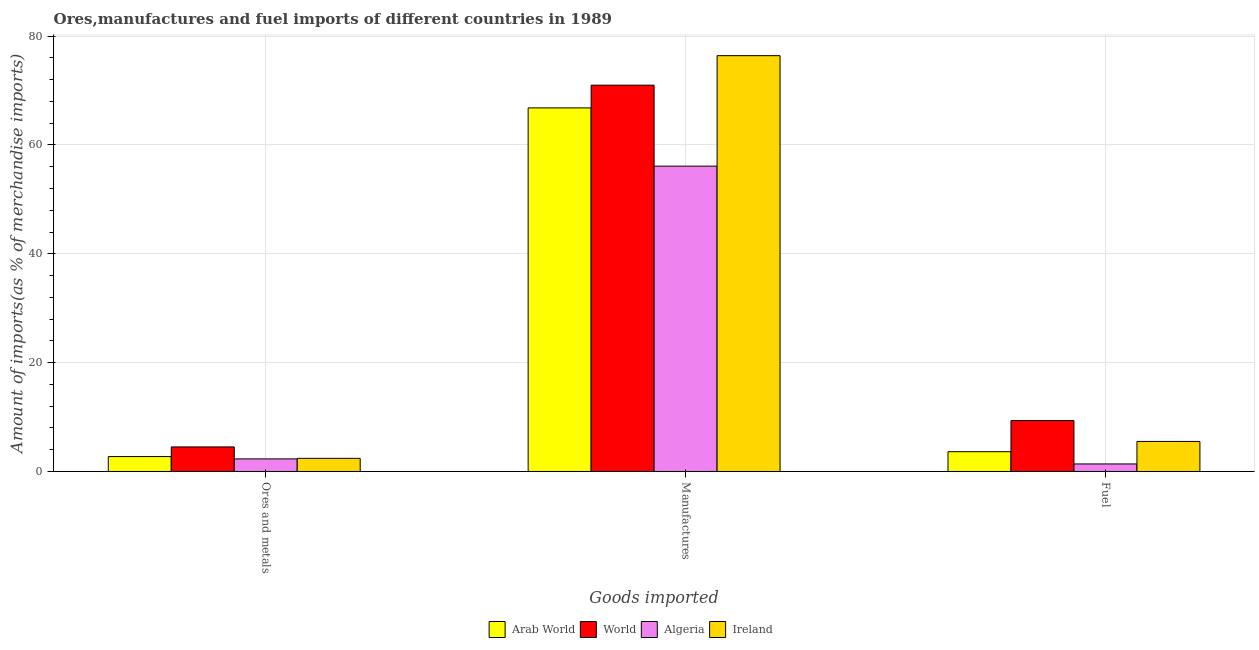How many different coloured bars are there?
Your answer should be very brief. 4. Are the number of bars per tick equal to the number of legend labels?
Offer a very short reply. Yes. How many bars are there on the 2nd tick from the left?
Offer a very short reply. 4. How many bars are there on the 2nd tick from the right?
Keep it short and to the point. 4. What is the label of the 1st group of bars from the left?
Give a very brief answer. Ores and metals. What is the percentage of fuel imports in Ireland?
Ensure brevity in your answer.  5.52. Across all countries, what is the maximum percentage of manufactures imports?
Provide a short and direct response. 76.4. Across all countries, what is the minimum percentage of ores and metals imports?
Provide a succinct answer. 2.31. In which country was the percentage of manufactures imports minimum?
Your response must be concise. Algeria. What is the total percentage of manufactures imports in the graph?
Ensure brevity in your answer.  270.28. What is the difference between the percentage of fuel imports in Arab World and that in Ireland?
Keep it short and to the point. -1.89. What is the difference between the percentage of ores and metals imports in Ireland and the percentage of manufactures imports in Algeria?
Keep it short and to the point. -53.68. What is the average percentage of fuel imports per country?
Keep it short and to the point. 4.97. What is the difference between the percentage of fuel imports and percentage of manufactures imports in Algeria?
Give a very brief answer. -54.72. In how many countries, is the percentage of ores and metals imports greater than 24 %?
Provide a succinct answer. 0. What is the ratio of the percentage of fuel imports in Arab World to that in Ireland?
Your response must be concise. 0.66. Is the percentage of fuel imports in Ireland less than that in Arab World?
Your response must be concise. No. What is the difference between the highest and the second highest percentage of ores and metals imports?
Make the answer very short. 1.77. What is the difference between the highest and the lowest percentage of ores and metals imports?
Your response must be concise. 2.2. In how many countries, is the percentage of fuel imports greater than the average percentage of fuel imports taken over all countries?
Provide a succinct answer. 2. What does the 3rd bar from the left in Ores and metals represents?
Offer a terse response. Algeria. What does the 4th bar from the right in Ores and metals represents?
Provide a short and direct response. Arab World. How many bars are there?
Offer a very short reply. 12. What is the difference between two consecutive major ticks on the Y-axis?
Provide a succinct answer. 20. Where does the legend appear in the graph?
Offer a very short reply. Bottom center. What is the title of the graph?
Provide a succinct answer. Ores,manufactures and fuel imports of different countries in 1989. Does "Pakistan" appear as one of the legend labels in the graph?
Offer a terse response. No. What is the label or title of the X-axis?
Your response must be concise. Goods imported. What is the label or title of the Y-axis?
Provide a succinct answer. Amount of imports(as % of merchandise imports). What is the Amount of imports(as % of merchandise imports) of Arab World in Ores and metals?
Offer a very short reply. 2.74. What is the Amount of imports(as % of merchandise imports) in World in Ores and metals?
Ensure brevity in your answer.  4.51. What is the Amount of imports(as % of merchandise imports) of Algeria in Ores and metals?
Your answer should be very brief. 2.31. What is the Amount of imports(as % of merchandise imports) in Ireland in Ores and metals?
Offer a terse response. 2.42. What is the Amount of imports(as % of merchandise imports) in Arab World in Manufactures?
Provide a succinct answer. 66.8. What is the Amount of imports(as % of merchandise imports) in World in Manufactures?
Offer a very short reply. 70.98. What is the Amount of imports(as % of merchandise imports) in Algeria in Manufactures?
Provide a succinct answer. 56.1. What is the Amount of imports(as % of merchandise imports) in Ireland in Manufactures?
Your answer should be compact. 76.4. What is the Amount of imports(as % of merchandise imports) in Arab World in Fuel?
Give a very brief answer. 3.64. What is the Amount of imports(as % of merchandise imports) of World in Fuel?
Your answer should be very brief. 9.36. What is the Amount of imports(as % of merchandise imports) of Algeria in Fuel?
Keep it short and to the point. 1.38. What is the Amount of imports(as % of merchandise imports) in Ireland in Fuel?
Offer a very short reply. 5.52. Across all Goods imported, what is the maximum Amount of imports(as % of merchandise imports) of Arab World?
Ensure brevity in your answer.  66.8. Across all Goods imported, what is the maximum Amount of imports(as % of merchandise imports) in World?
Offer a very short reply. 70.98. Across all Goods imported, what is the maximum Amount of imports(as % of merchandise imports) of Algeria?
Keep it short and to the point. 56.1. Across all Goods imported, what is the maximum Amount of imports(as % of merchandise imports) in Ireland?
Your answer should be very brief. 76.4. Across all Goods imported, what is the minimum Amount of imports(as % of merchandise imports) of Arab World?
Keep it short and to the point. 2.74. Across all Goods imported, what is the minimum Amount of imports(as % of merchandise imports) in World?
Keep it short and to the point. 4.51. Across all Goods imported, what is the minimum Amount of imports(as % of merchandise imports) in Algeria?
Keep it short and to the point. 1.38. Across all Goods imported, what is the minimum Amount of imports(as % of merchandise imports) in Ireland?
Give a very brief answer. 2.42. What is the total Amount of imports(as % of merchandise imports) in Arab World in the graph?
Offer a terse response. 73.18. What is the total Amount of imports(as % of merchandise imports) of World in the graph?
Provide a succinct answer. 84.85. What is the total Amount of imports(as % of merchandise imports) in Algeria in the graph?
Your answer should be compact. 59.8. What is the total Amount of imports(as % of merchandise imports) in Ireland in the graph?
Your answer should be very brief. 84.34. What is the difference between the Amount of imports(as % of merchandise imports) of Arab World in Ores and metals and that in Manufactures?
Your answer should be very brief. -64.06. What is the difference between the Amount of imports(as % of merchandise imports) of World in Ores and metals and that in Manufactures?
Your answer should be very brief. -66.47. What is the difference between the Amount of imports(as % of merchandise imports) in Algeria in Ores and metals and that in Manufactures?
Ensure brevity in your answer.  -53.79. What is the difference between the Amount of imports(as % of merchandise imports) of Ireland in Ores and metals and that in Manufactures?
Offer a terse response. -73.98. What is the difference between the Amount of imports(as % of merchandise imports) in Arab World in Ores and metals and that in Fuel?
Keep it short and to the point. -0.89. What is the difference between the Amount of imports(as % of merchandise imports) of World in Ores and metals and that in Fuel?
Offer a terse response. -4.84. What is the difference between the Amount of imports(as % of merchandise imports) in Algeria in Ores and metals and that in Fuel?
Your answer should be compact. 0.93. What is the difference between the Amount of imports(as % of merchandise imports) in Ireland in Ores and metals and that in Fuel?
Keep it short and to the point. -3.1. What is the difference between the Amount of imports(as % of merchandise imports) in Arab World in Manufactures and that in Fuel?
Your answer should be very brief. 63.17. What is the difference between the Amount of imports(as % of merchandise imports) in World in Manufactures and that in Fuel?
Offer a very short reply. 61.62. What is the difference between the Amount of imports(as % of merchandise imports) of Algeria in Manufactures and that in Fuel?
Make the answer very short. 54.72. What is the difference between the Amount of imports(as % of merchandise imports) in Ireland in Manufactures and that in Fuel?
Provide a short and direct response. 70.88. What is the difference between the Amount of imports(as % of merchandise imports) of Arab World in Ores and metals and the Amount of imports(as % of merchandise imports) of World in Manufactures?
Make the answer very short. -68.24. What is the difference between the Amount of imports(as % of merchandise imports) of Arab World in Ores and metals and the Amount of imports(as % of merchandise imports) of Algeria in Manufactures?
Keep it short and to the point. -53.36. What is the difference between the Amount of imports(as % of merchandise imports) in Arab World in Ores and metals and the Amount of imports(as % of merchandise imports) in Ireland in Manufactures?
Provide a succinct answer. -73.66. What is the difference between the Amount of imports(as % of merchandise imports) in World in Ores and metals and the Amount of imports(as % of merchandise imports) in Algeria in Manufactures?
Your response must be concise. -51.59. What is the difference between the Amount of imports(as % of merchandise imports) of World in Ores and metals and the Amount of imports(as % of merchandise imports) of Ireland in Manufactures?
Your response must be concise. -71.89. What is the difference between the Amount of imports(as % of merchandise imports) of Algeria in Ores and metals and the Amount of imports(as % of merchandise imports) of Ireland in Manufactures?
Your response must be concise. -74.09. What is the difference between the Amount of imports(as % of merchandise imports) of Arab World in Ores and metals and the Amount of imports(as % of merchandise imports) of World in Fuel?
Keep it short and to the point. -6.62. What is the difference between the Amount of imports(as % of merchandise imports) in Arab World in Ores and metals and the Amount of imports(as % of merchandise imports) in Algeria in Fuel?
Offer a very short reply. 1.36. What is the difference between the Amount of imports(as % of merchandise imports) in Arab World in Ores and metals and the Amount of imports(as % of merchandise imports) in Ireland in Fuel?
Provide a succinct answer. -2.78. What is the difference between the Amount of imports(as % of merchandise imports) in World in Ores and metals and the Amount of imports(as % of merchandise imports) in Algeria in Fuel?
Your answer should be compact. 3.13. What is the difference between the Amount of imports(as % of merchandise imports) of World in Ores and metals and the Amount of imports(as % of merchandise imports) of Ireland in Fuel?
Provide a succinct answer. -1.01. What is the difference between the Amount of imports(as % of merchandise imports) of Algeria in Ores and metals and the Amount of imports(as % of merchandise imports) of Ireland in Fuel?
Your answer should be compact. -3.21. What is the difference between the Amount of imports(as % of merchandise imports) of Arab World in Manufactures and the Amount of imports(as % of merchandise imports) of World in Fuel?
Offer a very short reply. 57.44. What is the difference between the Amount of imports(as % of merchandise imports) of Arab World in Manufactures and the Amount of imports(as % of merchandise imports) of Algeria in Fuel?
Provide a succinct answer. 65.42. What is the difference between the Amount of imports(as % of merchandise imports) of Arab World in Manufactures and the Amount of imports(as % of merchandise imports) of Ireland in Fuel?
Offer a very short reply. 61.28. What is the difference between the Amount of imports(as % of merchandise imports) in World in Manufactures and the Amount of imports(as % of merchandise imports) in Algeria in Fuel?
Offer a terse response. 69.59. What is the difference between the Amount of imports(as % of merchandise imports) of World in Manufactures and the Amount of imports(as % of merchandise imports) of Ireland in Fuel?
Offer a very short reply. 65.46. What is the difference between the Amount of imports(as % of merchandise imports) of Algeria in Manufactures and the Amount of imports(as % of merchandise imports) of Ireland in Fuel?
Provide a succinct answer. 50.58. What is the average Amount of imports(as % of merchandise imports) of Arab World per Goods imported?
Offer a very short reply. 24.39. What is the average Amount of imports(as % of merchandise imports) in World per Goods imported?
Offer a terse response. 28.28. What is the average Amount of imports(as % of merchandise imports) of Algeria per Goods imported?
Keep it short and to the point. 19.93. What is the average Amount of imports(as % of merchandise imports) of Ireland per Goods imported?
Provide a short and direct response. 28.11. What is the difference between the Amount of imports(as % of merchandise imports) of Arab World and Amount of imports(as % of merchandise imports) of World in Ores and metals?
Give a very brief answer. -1.77. What is the difference between the Amount of imports(as % of merchandise imports) in Arab World and Amount of imports(as % of merchandise imports) in Algeria in Ores and metals?
Offer a terse response. 0.43. What is the difference between the Amount of imports(as % of merchandise imports) in Arab World and Amount of imports(as % of merchandise imports) in Ireland in Ores and metals?
Ensure brevity in your answer.  0.32. What is the difference between the Amount of imports(as % of merchandise imports) of World and Amount of imports(as % of merchandise imports) of Algeria in Ores and metals?
Your answer should be compact. 2.2. What is the difference between the Amount of imports(as % of merchandise imports) in World and Amount of imports(as % of merchandise imports) in Ireland in Ores and metals?
Offer a very short reply. 2.1. What is the difference between the Amount of imports(as % of merchandise imports) in Algeria and Amount of imports(as % of merchandise imports) in Ireland in Ores and metals?
Your response must be concise. -0.1. What is the difference between the Amount of imports(as % of merchandise imports) in Arab World and Amount of imports(as % of merchandise imports) in World in Manufactures?
Provide a succinct answer. -4.18. What is the difference between the Amount of imports(as % of merchandise imports) in Arab World and Amount of imports(as % of merchandise imports) in Algeria in Manufactures?
Provide a succinct answer. 10.7. What is the difference between the Amount of imports(as % of merchandise imports) of Arab World and Amount of imports(as % of merchandise imports) of Ireland in Manufactures?
Keep it short and to the point. -9.6. What is the difference between the Amount of imports(as % of merchandise imports) of World and Amount of imports(as % of merchandise imports) of Algeria in Manufactures?
Your answer should be very brief. 14.88. What is the difference between the Amount of imports(as % of merchandise imports) in World and Amount of imports(as % of merchandise imports) in Ireland in Manufactures?
Offer a terse response. -5.42. What is the difference between the Amount of imports(as % of merchandise imports) of Algeria and Amount of imports(as % of merchandise imports) of Ireland in Manufactures?
Your answer should be compact. -20.3. What is the difference between the Amount of imports(as % of merchandise imports) of Arab World and Amount of imports(as % of merchandise imports) of World in Fuel?
Ensure brevity in your answer.  -5.72. What is the difference between the Amount of imports(as % of merchandise imports) in Arab World and Amount of imports(as % of merchandise imports) in Algeria in Fuel?
Offer a terse response. 2.25. What is the difference between the Amount of imports(as % of merchandise imports) of Arab World and Amount of imports(as % of merchandise imports) of Ireland in Fuel?
Your answer should be compact. -1.89. What is the difference between the Amount of imports(as % of merchandise imports) of World and Amount of imports(as % of merchandise imports) of Algeria in Fuel?
Your response must be concise. 7.97. What is the difference between the Amount of imports(as % of merchandise imports) in World and Amount of imports(as % of merchandise imports) in Ireland in Fuel?
Give a very brief answer. 3.84. What is the difference between the Amount of imports(as % of merchandise imports) in Algeria and Amount of imports(as % of merchandise imports) in Ireland in Fuel?
Your response must be concise. -4.14. What is the ratio of the Amount of imports(as % of merchandise imports) in Arab World in Ores and metals to that in Manufactures?
Ensure brevity in your answer.  0.04. What is the ratio of the Amount of imports(as % of merchandise imports) in World in Ores and metals to that in Manufactures?
Your answer should be compact. 0.06. What is the ratio of the Amount of imports(as % of merchandise imports) of Algeria in Ores and metals to that in Manufactures?
Your answer should be compact. 0.04. What is the ratio of the Amount of imports(as % of merchandise imports) in Ireland in Ores and metals to that in Manufactures?
Your answer should be very brief. 0.03. What is the ratio of the Amount of imports(as % of merchandise imports) in Arab World in Ores and metals to that in Fuel?
Offer a terse response. 0.75. What is the ratio of the Amount of imports(as % of merchandise imports) in World in Ores and metals to that in Fuel?
Your answer should be very brief. 0.48. What is the ratio of the Amount of imports(as % of merchandise imports) in Algeria in Ores and metals to that in Fuel?
Offer a very short reply. 1.67. What is the ratio of the Amount of imports(as % of merchandise imports) of Ireland in Ores and metals to that in Fuel?
Your response must be concise. 0.44. What is the ratio of the Amount of imports(as % of merchandise imports) of Arab World in Manufactures to that in Fuel?
Provide a short and direct response. 18.38. What is the ratio of the Amount of imports(as % of merchandise imports) in World in Manufactures to that in Fuel?
Give a very brief answer. 7.59. What is the ratio of the Amount of imports(as % of merchandise imports) in Algeria in Manufactures to that in Fuel?
Make the answer very short. 40.54. What is the ratio of the Amount of imports(as % of merchandise imports) in Ireland in Manufactures to that in Fuel?
Give a very brief answer. 13.84. What is the difference between the highest and the second highest Amount of imports(as % of merchandise imports) in Arab World?
Give a very brief answer. 63.17. What is the difference between the highest and the second highest Amount of imports(as % of merchandise imports) in World?
Provide a succinct answer. 61.62. What is the difference between the highest and the second highest Amount of imports(as % of merchandise imports) in Algeria?
Make the answer very short. 53.79. What is the difference between the highest and the second highest Amount of imports(as % of merchandise imports) in Ireland?
Your answer should be very brief. 70.88. What is the difference between the highest and the lowest Amount of imports(as % of merchandise imports) in Arab World?
Offer a very short reply. 64.06. What is the difference between the highest and the lowest Amount of imports(as % of merchandise imports) in World?
Ensure brevity in your answer.  66.47. What is the difference between the highest and the lowest Amount of imports(as % of merchandise imports) of Algeria?
Make the answer very short. 54.72. What is the difference between the highest and the lowest Amount of imports(as % of merchandise imports) in Ireland?
Keep it short and to the point. 73.98. 